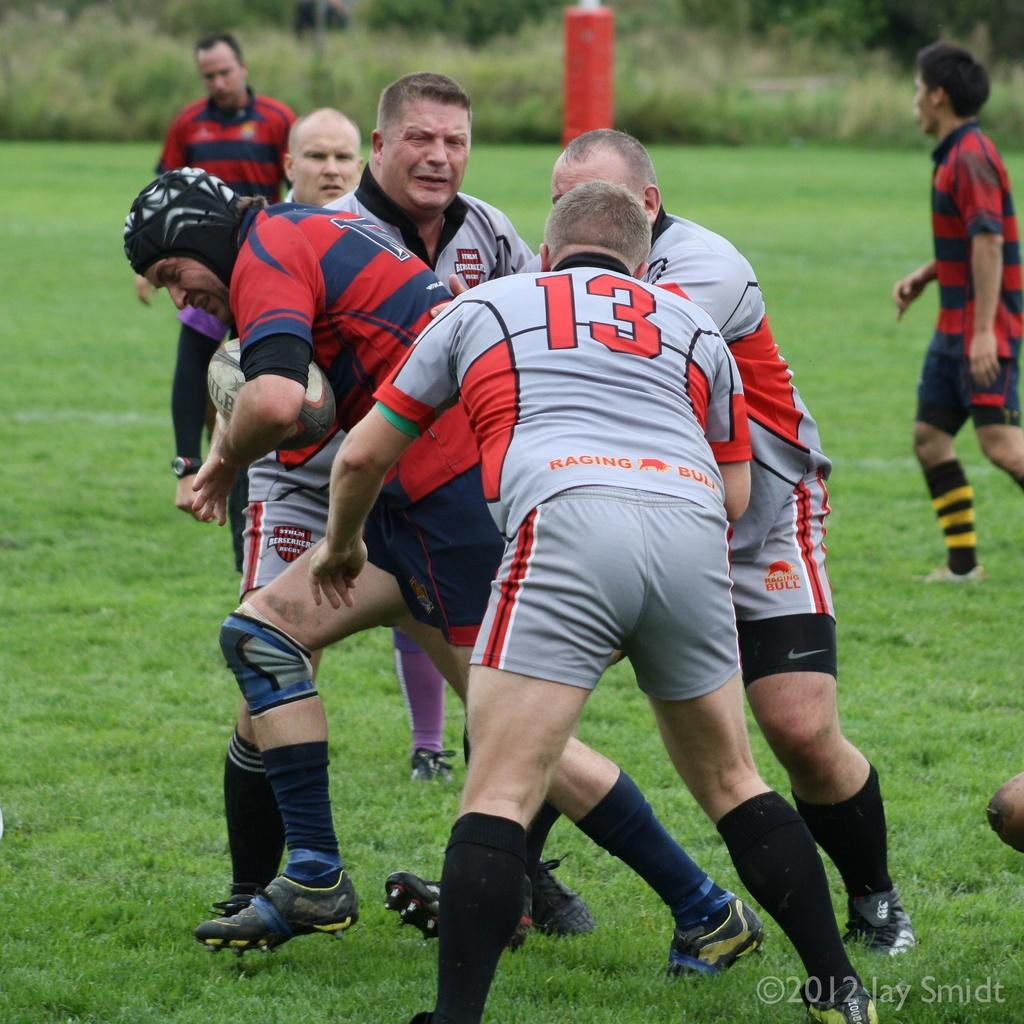Where was the image taken? The image was taken in a garden. What are the people in the image doing? The people in the image are playing a game. What can be seen in the background of the image? There are green color trees in the background of the image. What type of bomb is being diffused in the image? There is no bomb present in the image; it is a scene in a garden with people playing a game. 